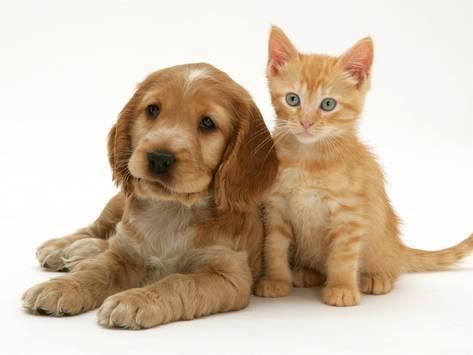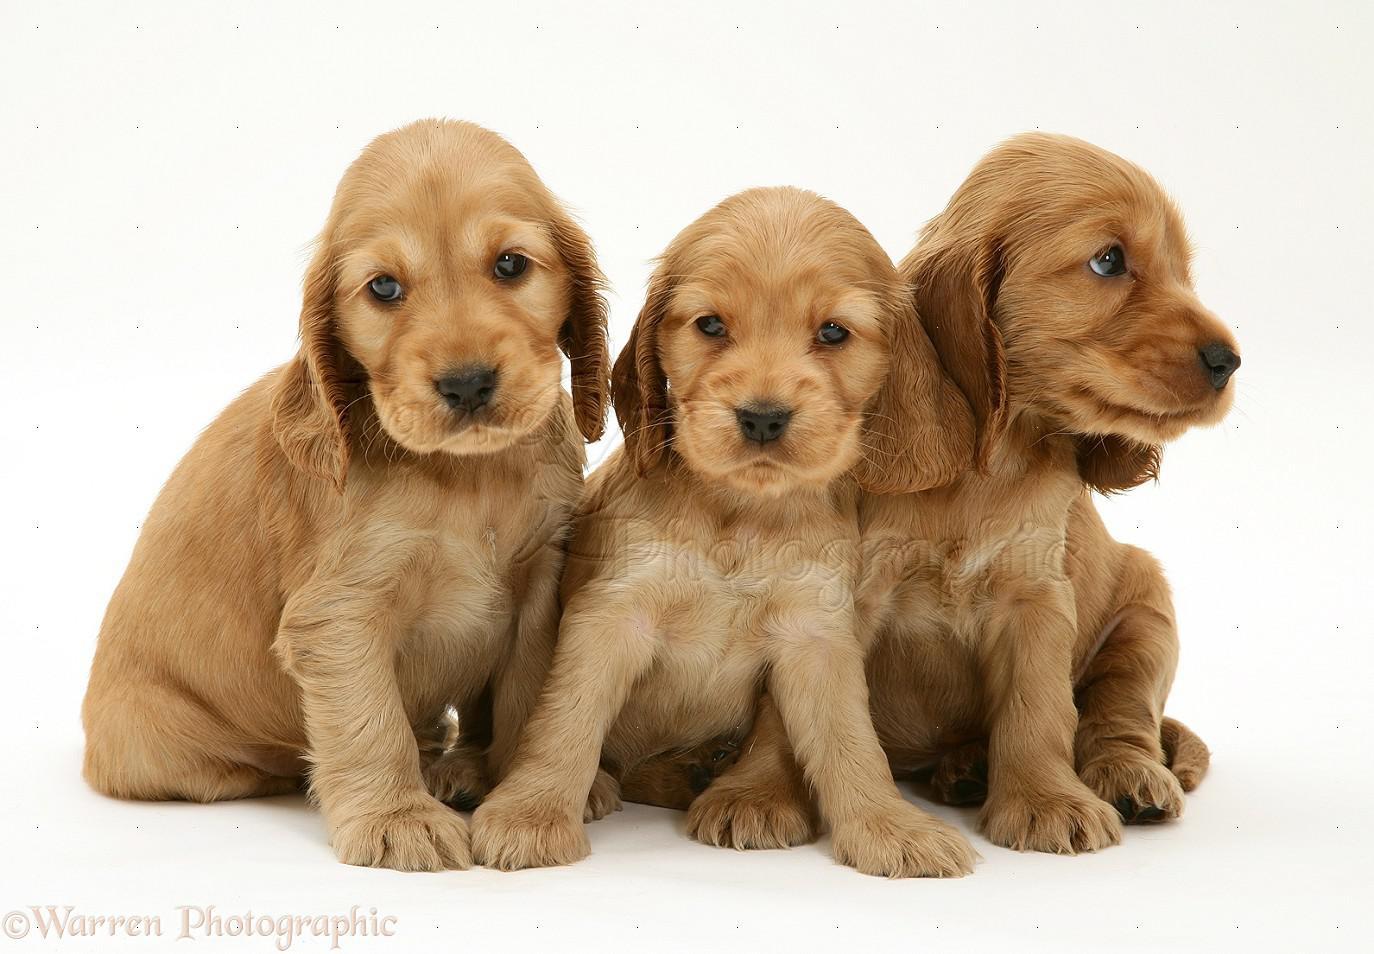The first image is the image on the left, the second image is the image on the right. Assess this claim about the two images: "One image shows a golden-haired puppy posing with an animal that is not a puppy.". Correct or not? Answer yes or no. Yes. The first image is the image on the left, the second image is the image on the right. For the images shown, is this caption "There's at least two dogs in the right image." true? Answer yes or no. Yes. 